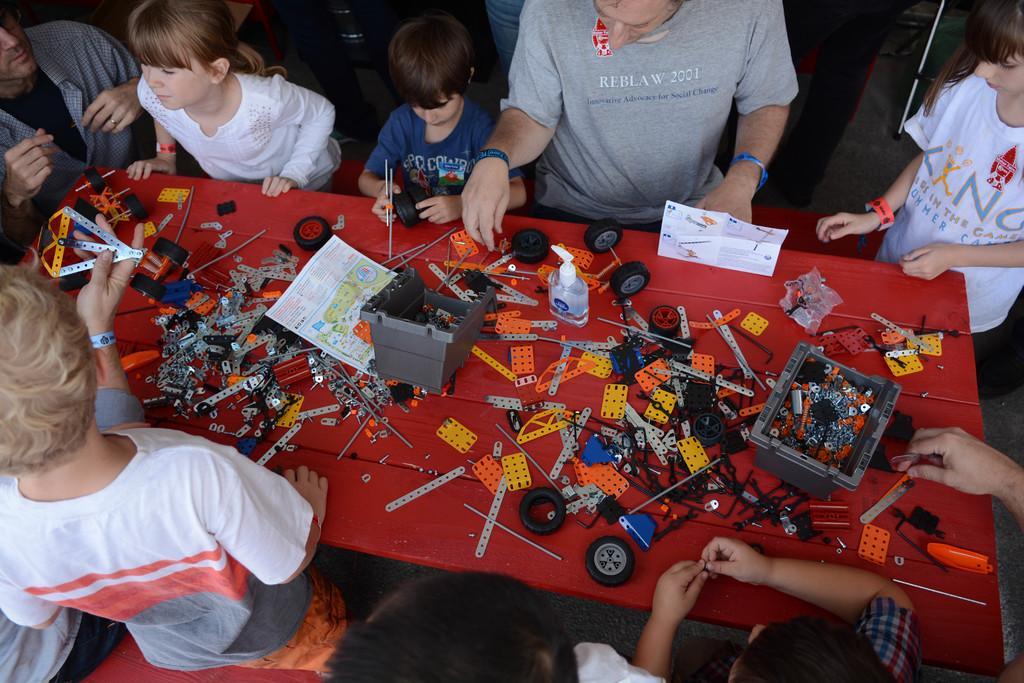Please provide a concise description of this image. In this image I can see a table , on the table I can see a red color cloth. Around the table I can see few persons standing and some objects kept on that. 